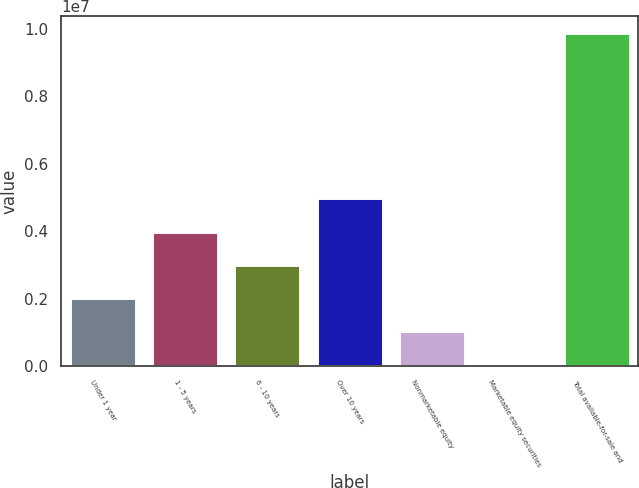Convert chart to OTSL. <chart><loc_0><loc_0><loc_500><loc_500><bar_chart><fcel>Under 1 year<fcel>1 - 5 years<fcel>6 - 10 years<fcel>Over 10 years<fcel>Nonmarketable equity<fcel>Marketable equity securities<fcel>Total available-for-sale and<nl><fcel>2.02168e+06<fcel>3.99007e+06<fcel>3.00587e+06<fcel>4.97426e+06<fcel>1.03748e+06<fcel>53286<fcel>9.89524e+06<nl></chart> 